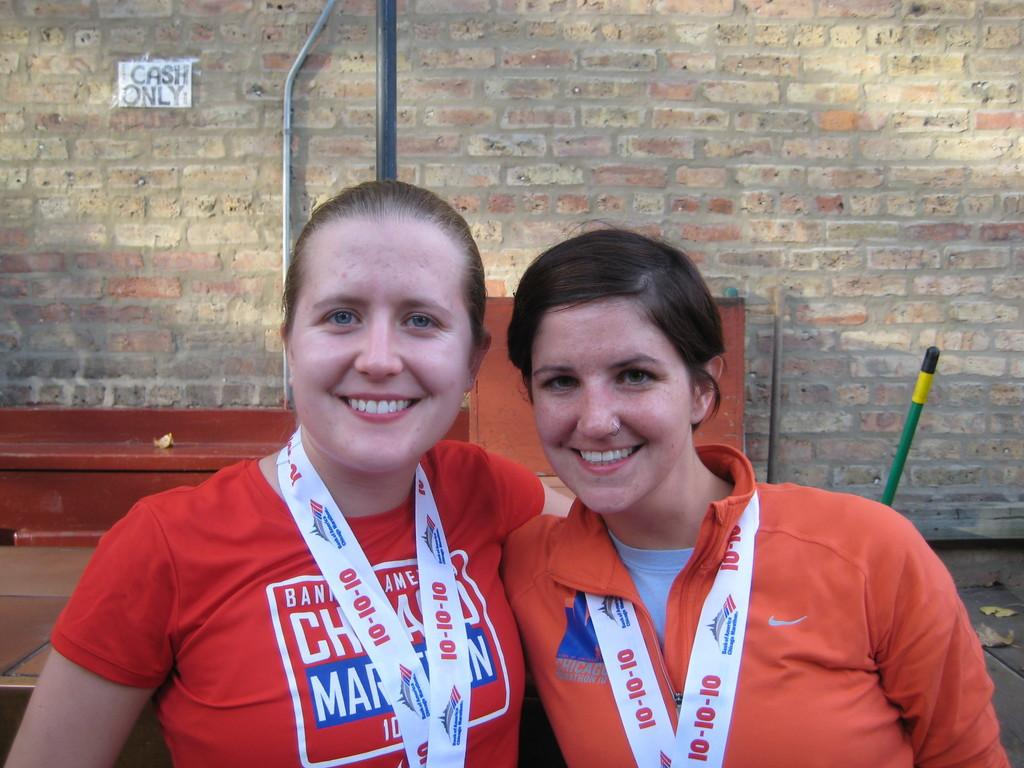<image>
Relay a brief, clear account of the picture shown. Two women wearing Bank of America sashes are posed in front of a cash only sign. 